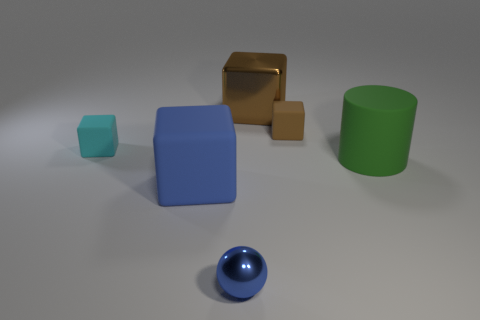What size is the matte block that is the same color as the small ball?
Provide a succinct answer. Large. There is a shiny thing that is the same color as the large matte cube; what is its shape?
Ensure brevity in your answer.  Sphere. There is a small object that is the same color as the large matte block; what is it made of?
Offer a very short reply. Metal. What is the material of the block that is the same size as the brown shiny thing?
Your response must be concise. Rubber. How many small objects are shiny spheres or purple rubber spheres?
Offer a very short reply. 1. Are any big green metal cylinders visible?
Provide a succinct answer. No. There is a brown block that is made of the same material as the small sphere; what size is it?
Your response must be concise. Large. Does the large brown block have the same material as the large cylinder?
Make the answer very short. No. What number of other objects are there of the same material as the cyan thing?
Your answer should be compact. 3. How many small objects are behind the cyan matte thing and on the left side of the large brown metal cube?
Your answer should be very brief. 0. 